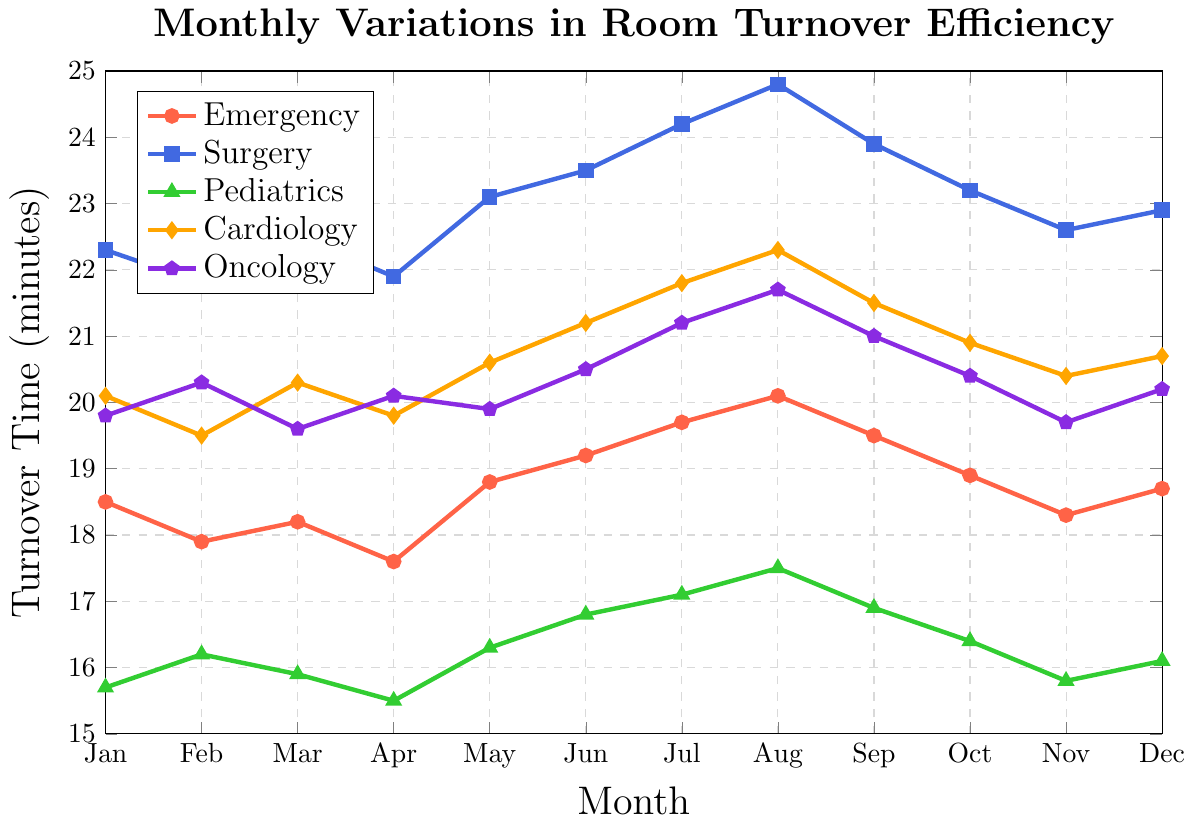Which hospital unit has the highest turnover time in August? Look at the data points for August and compare them. Surgery has 24.8 minutes, which is the highest.
Answer: Surgery Which unit had the lowest turnover time in March? Compare the values for March across all units. Pediatrics has the lowest at 15.9 minutes.
Answer: Pediatrics During which month did the emergency unit have the best turnover time? The best turnover time is the lowest value. In the data for the emergency unit, the lowest value is 17.6 in April.
Answer: April What is the average room turnover time in January across all units? Sum the January values for all units (18.5 + 22.3 + 15.7 + 20.1 + 19.8) and divide by the number of units (5). Calculation: (18.5 + 22.3 + 15.7 + 20.1 + 19.8) / 5 = 19.28
Answer: 19.28 How does the emergency unit’s turnover time change from January to July? Compare the emergency unit's turnover times in January and July. January has 18.5 and July has 19.7, a 1.2-minute increase.
Answer: Increase by 1.2 minutes Which hospital unit experienced the most variation in room turnover times over the year? Calculate the range (max - min) for each unit and compare. Surgery ranges from 21.8 to 24.8, cardiology from 19.5 to 22.3, pediatrics from 15.5 to 17.5, oncology from 19.6 to 21.7, and emergency from 17.6 to 20.1. Surgery has the widest range (3.0).
Answer: Surgery What is the difference in room turnover times between the emergency and surgery units in July? Subtract the emergency unit's July value from the surgery unit's July value: 24.2 - 19.7 = 4.5.
Answer: 4.5 Which month has the highest average turnover time across all units? Calculate the average for each month and compare. The highest monthly average is in August: (20.1 + 24.8 + 17.5 + 22.3 + 21.7) / 5 = 21.28.
Answer: August 